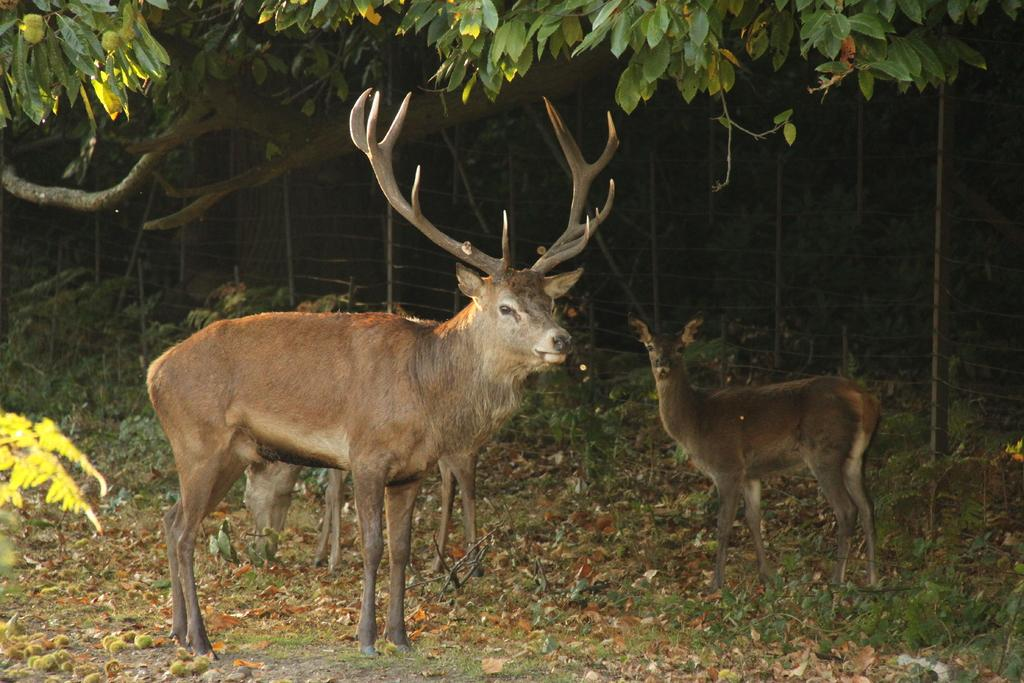What animals can be seen in the image? There are deer in the image. Where are the deer located? The deer are standing on the grassland. What can be seen in the background of the image? There are trees visible in the background of the image. What type of spoon is being used by the deer in the image? There are no spoons present in the image, as the deer are wild animals and do not use utensils. 